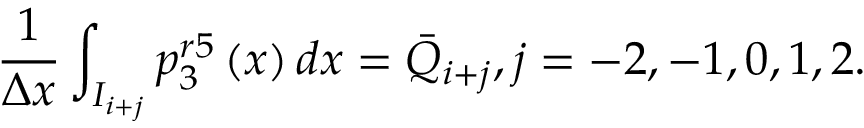<formula> <loc_0><loc_0><loc_500><loc_500>\frac { 1 } { \Delta x } \int _ { { { I } _ { i + j } } } { p _ { 3 } ^ { r 5 } \left ( x \right ) d x } = { { \bar { Q } } _ { i + j } } , j = - 2 , - 1 , 0 , 1 , 2 .</formula> 